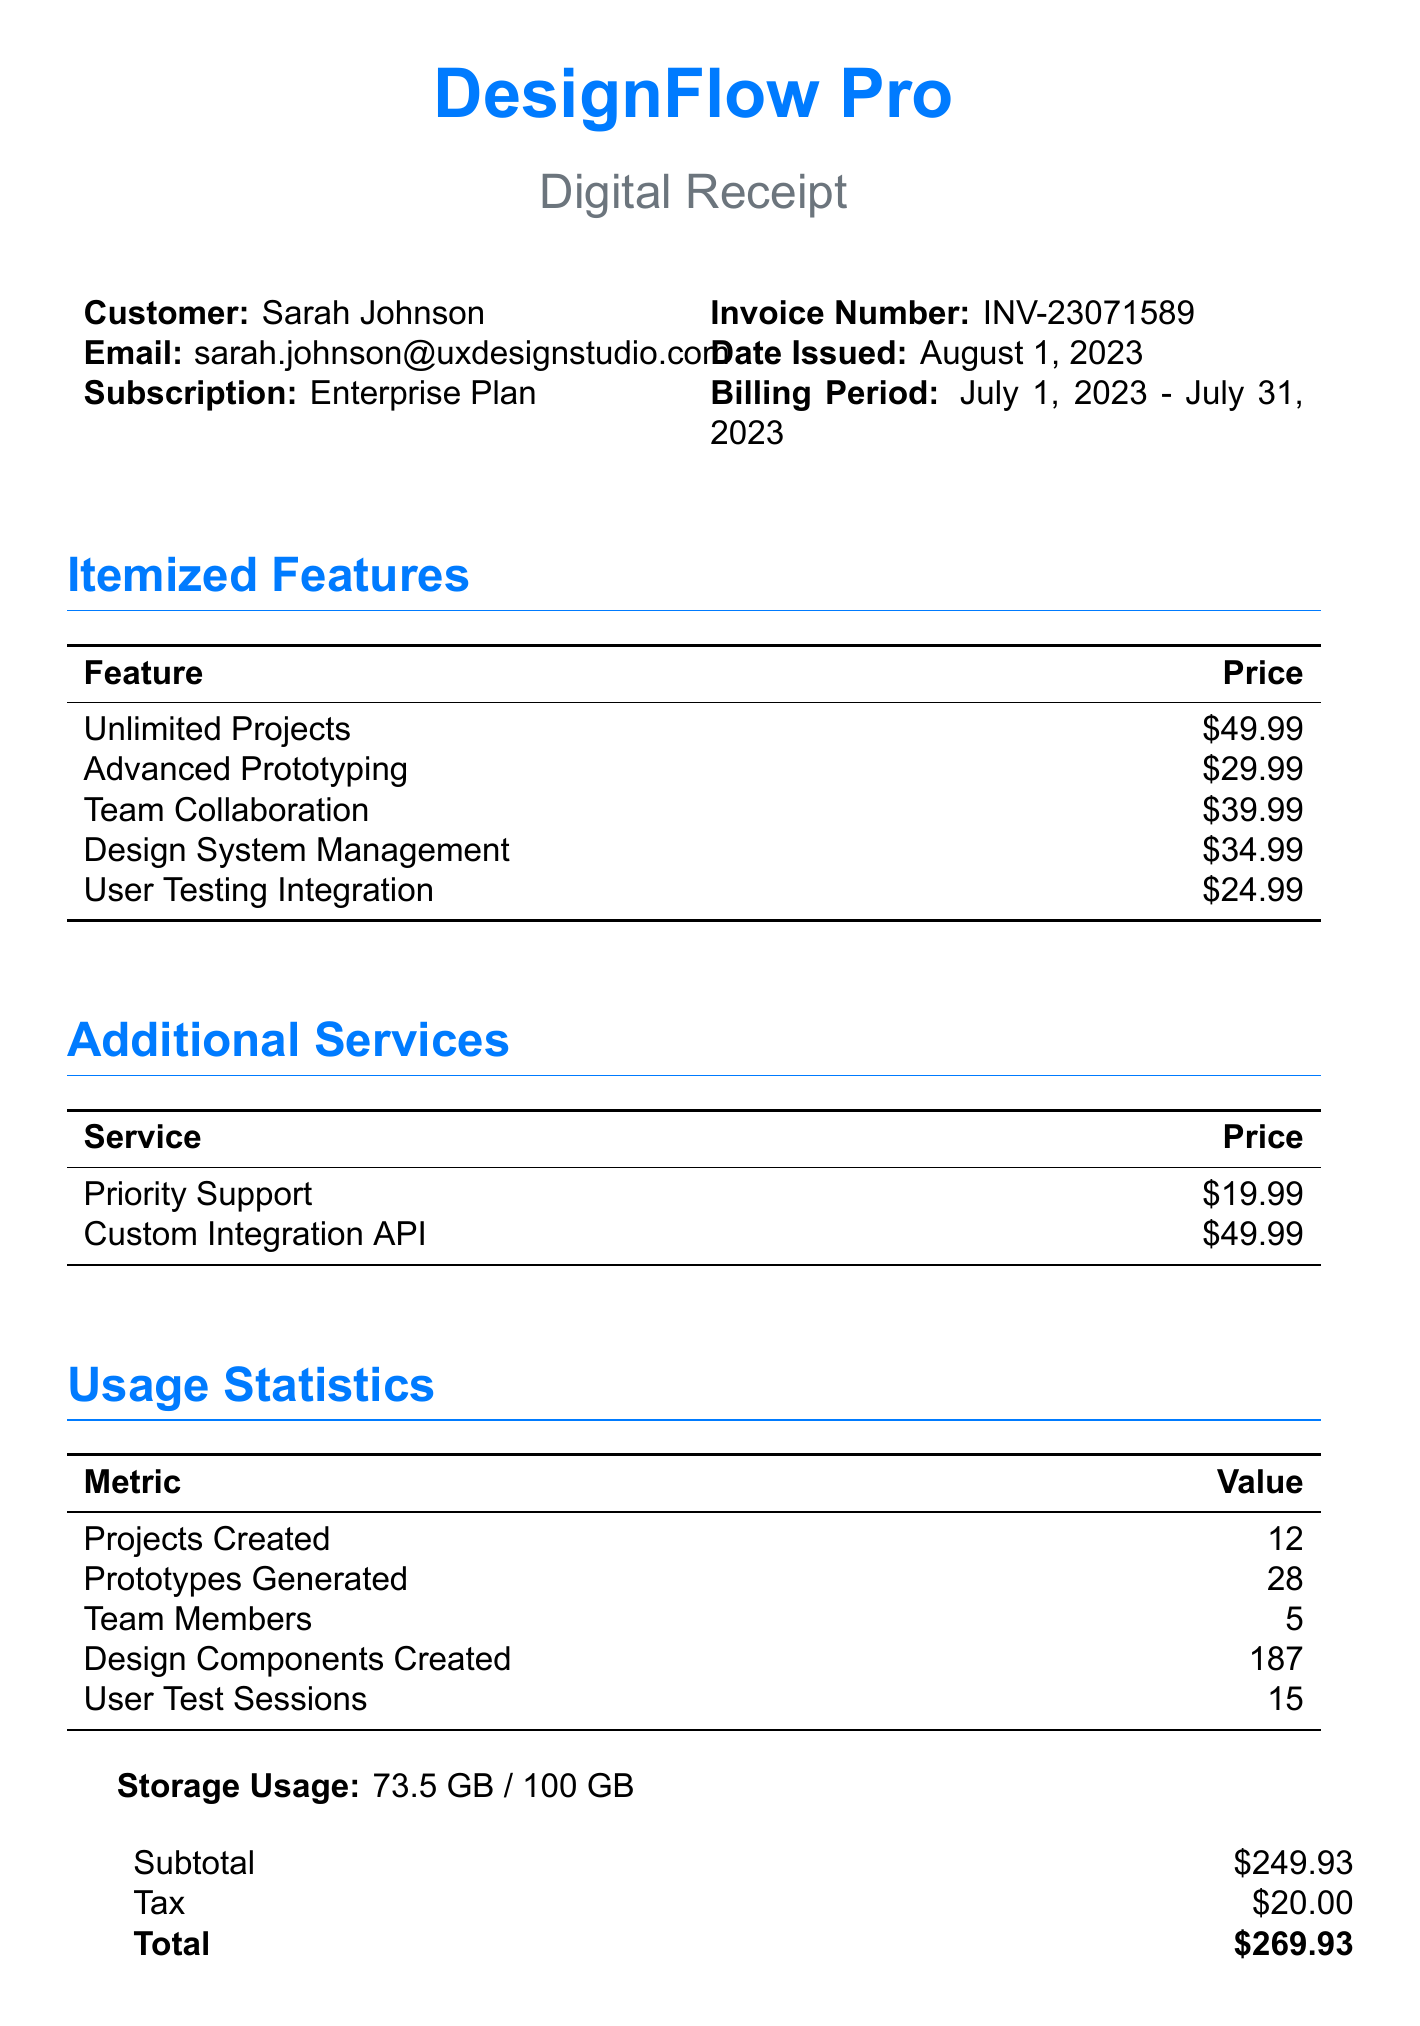What is the total amount due? The total amount due is listed at the bottom of the receipt, which includes subtotal and tax.
Answer: $269.93 Who is the customer? The customer's name is mentioned at the start of the document.
Answer: Sarah Johnson What is the billing period? The billing period for the subscription is specified in the document.
Answer: July 1, 2023 - July 31, 2023 How many projects were created? The metric for projects created is in the usage statistics section of the document.
Answer: 12 What feature is priced at $39.99? The itemized features section lists different features and their prices.
Answer: Team Collaboration What is the next billing date? The next billing date is highlighted at the end of the document.
Answer: September 1, 2023 What type of subscription does the customer have? The type of subscription is indicated alongside the customer details.
Answer: Enterprise Plan How much storage is used? The storage usage section mentions the amount of used storage.
Answer: 73.5 GB Which payment method was used? The payment method section provides details about how the payment was made.
Answer: Credit Card (ending in 4578) 